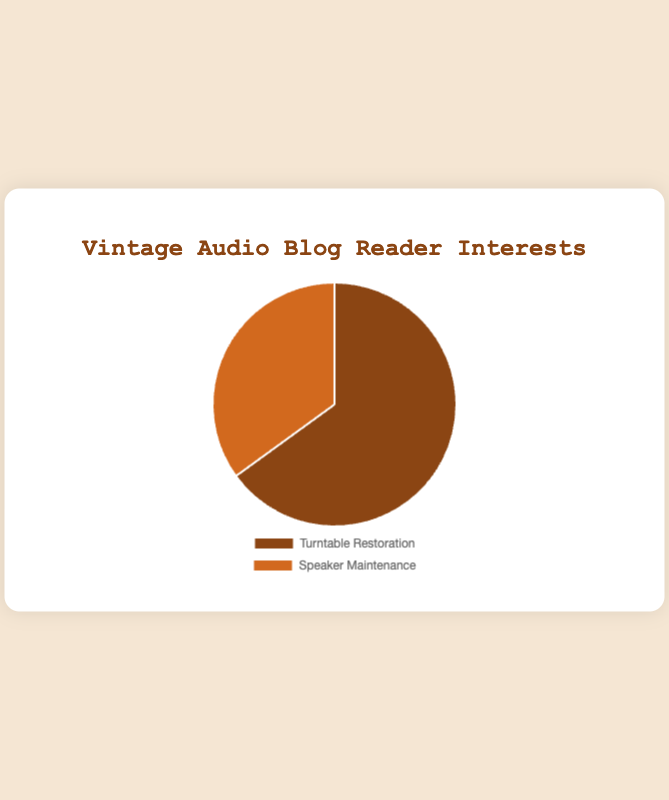What's the proportion of blog readers interested in turntable restoration? The chart is divided into two segments. The segment for Turntable Restoration has a percentage label of 65%.
Answer: 65% Which category has more interested readers, turntable restoration or speaker maintenance? Comparing the two segments, Turntable Restoration shows 65%, while Speaker Maintenance shows 35%. Therefore, Turntable Restoration has more interested readers.
Answer: Turntable Restoration What's the percentage difference between readers interested in turntable restoration and speaker maintenance? The proportion for Turntable Restoration is 65%, and for Speaker Maintenance is 35%. The difference is calculated as 65% - 35%.
Answer: 30% What percentage of blog readers are interested in speaker maintenance? The chart shows that the percentage of readers interested in Speaker Maintenance is 35%.
Answer: 35% By how much does the interest in turntable restoration exceed the interest in speaker maintenance? The percentage for Turntable Restoration is 65%, and for Speaker Maintenance is 35%. The excess can be found by subtracting 35% from 65%.
Answer: 30% Which segment of the pie chart is larger, the one representing Turntable Restoration or Speaker Maintenance? Visually, the segment representing Turntable Restoration occupies a larger portion of the pie chart compared to the segment for Speaker Maintenance.
Answer: Turntable Restoration What is the combined percentage of blog readers interested in both turntable restoration and speaker maintenance? The chart shows the percentages for Turntable Restoration and Speaker Maintenance as 65% and 35%, respectively. Adding these gives 65% + 35% = 100%.
Answer: 100% If the segment for turntable restoration is colored brown, what is the color of the segment for speaker maintenance? The chart shows the segment for Turntable Restoration in brown and the segment for Speaker Maintenance in a different color. Given the typical color scheme, the segment for Speaker Maintenance is colored tan.
Answer: Tan What fraction of blog readers are interested in speaker maintenance? The percentage of readers interested in Speaker Maintenance is 35%, which corresponds to a fraction of 35/100. Simplifying this gives 7/20.
Answer: 7/20 By how much do the interests differ by percentage points? The difference in interest between Turntable Restoration (65%) and Speaker Maintenance (35%) is calculated by finding 65% - 35%, which is 30 percentage points.
Answer: 30 percentage points 